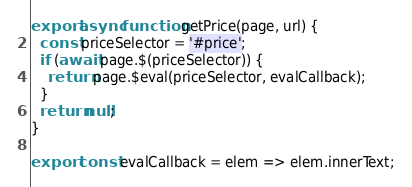Convert code to text. <code><loc_0><loc_0><loc_500><loc_500><_TypeScript_>export async function getPrice(page, url) {
  const priceSelector = '#price';
  if (await page.$(priceSelector)) {
    return page.$eval(priceSelector, evalCallback);
  }
  return null;
}

export const evalCallback = elem => elem.innerText;
</code> 